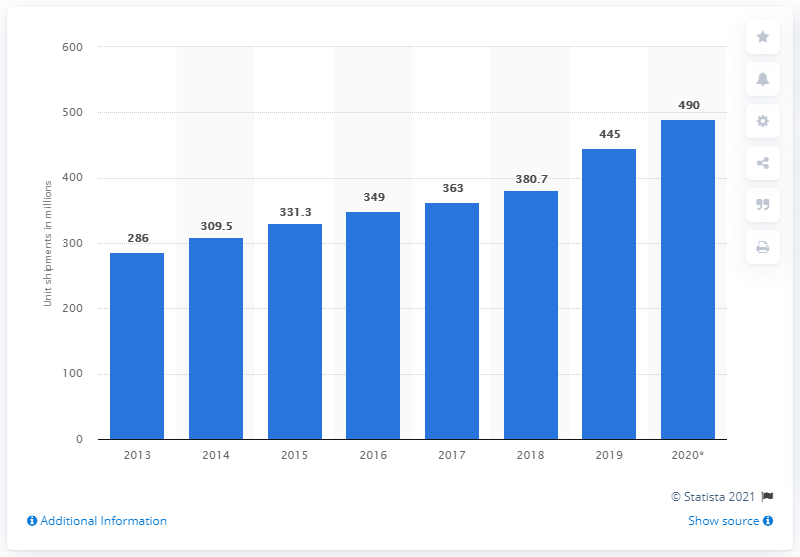Identify some key points in this picture. In 2019, an estimated 445 million headphones were sold worldwide. 